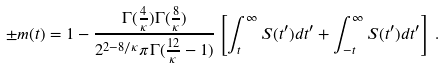Convert formula to latex. <formula><loc_0><loc_0><loc_500><loc_500>\pm m ( t ) = 1 - \frac { \Gamma ( \frac { 4 } { \kappa } ) \Gamma ( \frac { 8 } { \kappa } ) } { 2 ^ { 2 - 8 / \kappa } \pi \Gamma ( \frac { 1 2 } { \kappa } - 1 ) } \left [ \int _ { t } ^ { \infty } S ( t ^ { \prime } ) d t ^ { \prime } + \int _ { - t } ^ { \infty } S ( t ^ { \prime } ) d t ^ { \prime } \right ] \, .</formula> 